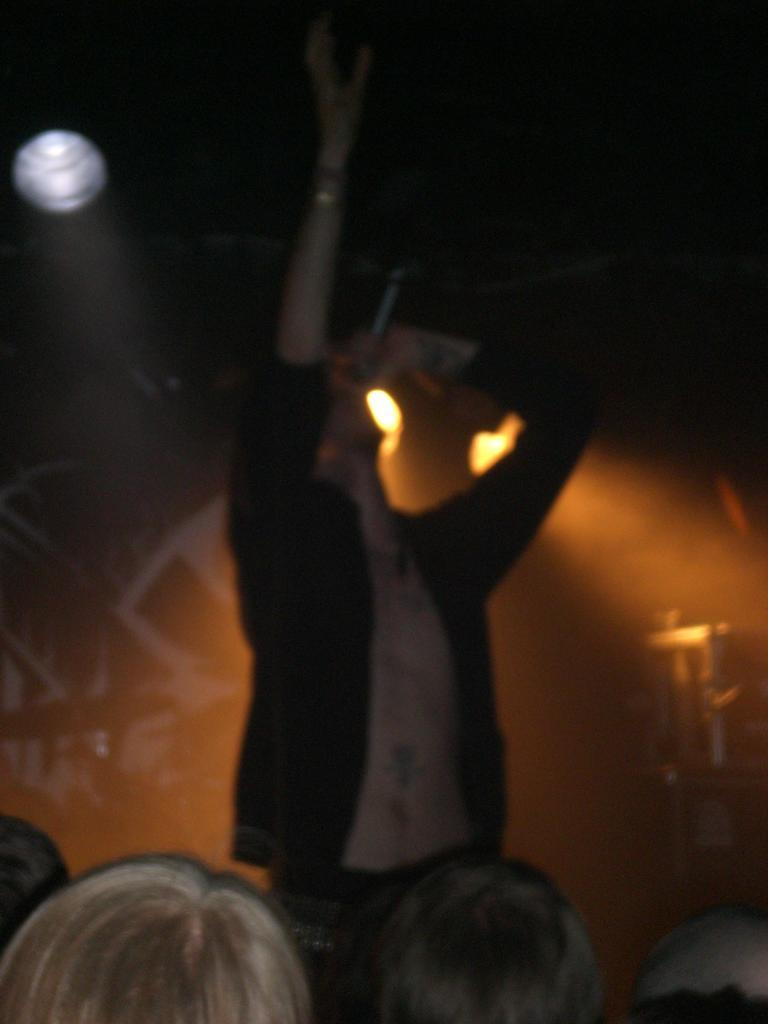What is the person in the image wearing? There is a person with a dress in the image. What is happening in front of the person? There is a group of people in front of the person. What can be seen in the background of the image? There are lights visible in the background. What is the color of the background in the image? The background of the image is black. How does the person in the image use a pencil to sort blood samples? There is no pencil or blood samples present in the image; the person is wearing a dress and standing in front of a group of people. 